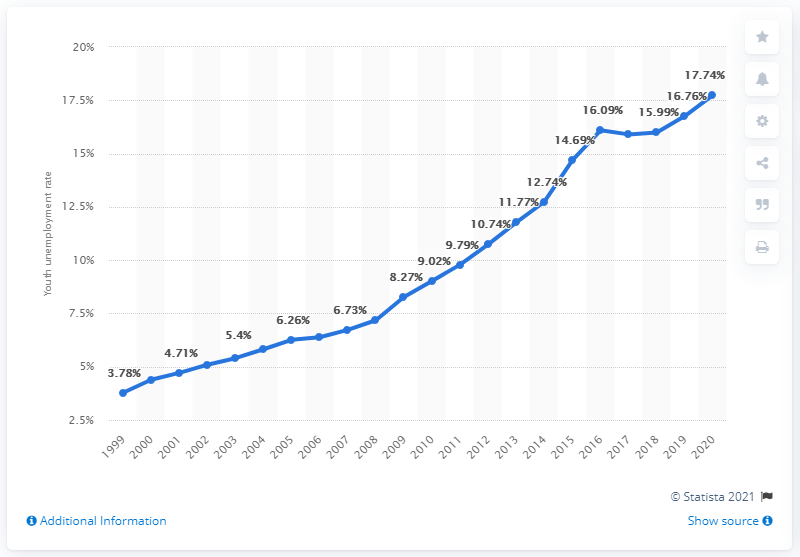Highlight a few significant elements in this photo. The youth unemployment rate in the Maldives in 2020 was 17.74%. 